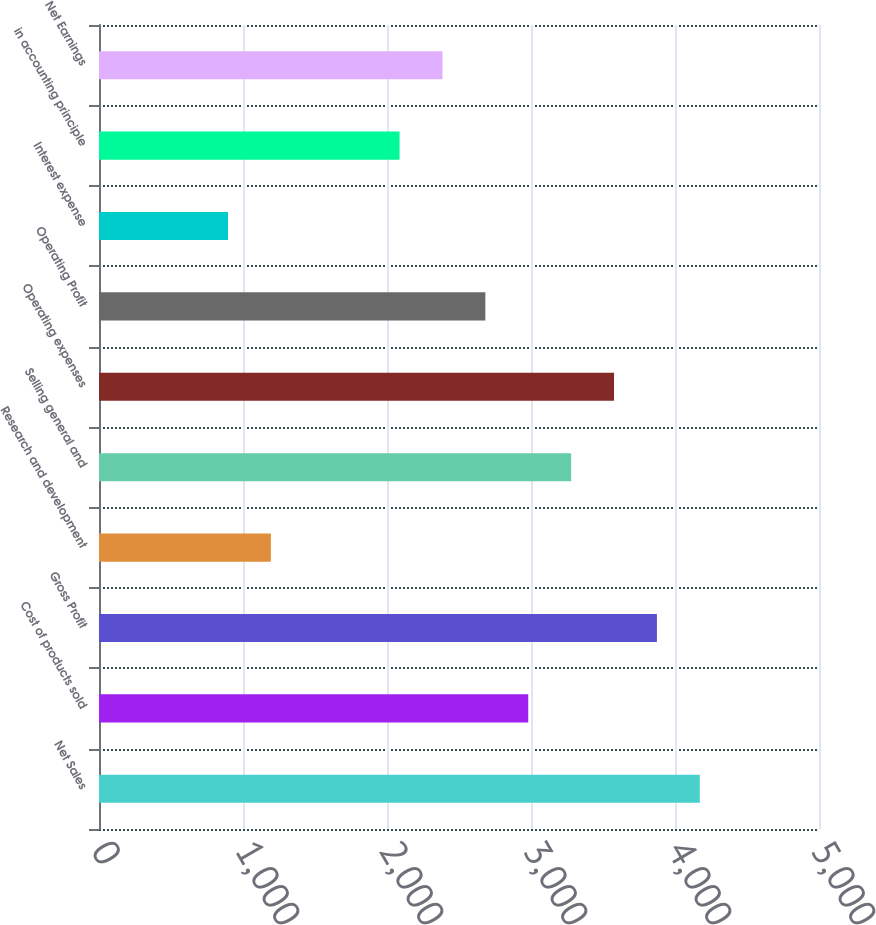Convert chart. <chart><loc_0><loc_0><loc_500><loc_500><bar_chart><fcel>Net Sales<fcel>Cost of products sold<fcel>Gross Profit<fcel>Research and development<fcel>Selling general and<fcel>Operating expenses<fcel>Operating Profit<fcel>Interest expense<fcel>in accounting principle<fcel>Net Earnings<nl><fcel>4172.37<fcel>2980.89<fcel>3874.5<fcel>1193.67<fcel>3278.76<fcel>3576.63<fcel>2683.02<fcel>895.8<fcel>2087.28<fcel>2385.15<nl></chart> 